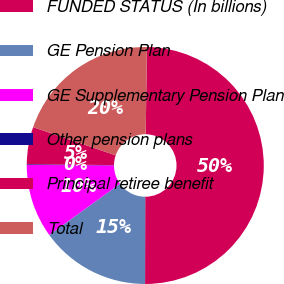<chart> <loc_0><loc_0><loc_500><loc_500><pie_chart><fcel>FUNDED STATUS (In billions)<fcel>GE Pension Plan<fcel>GE Supplementary Pension Plan<fcel>Other pension plans<fcel>Principal retiree benefit<fcel>Total<nl><fcel>49.8%<fcel>15.01%<fcel>10.04%<fcel>0.1%<fcel>5.07%<fcel>19.98%<nl></chart> 